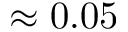Convert formula to latex. <formula><loc_0><loc_0><loc_500><loc_500>\approx 0 . 0 5</formula> 